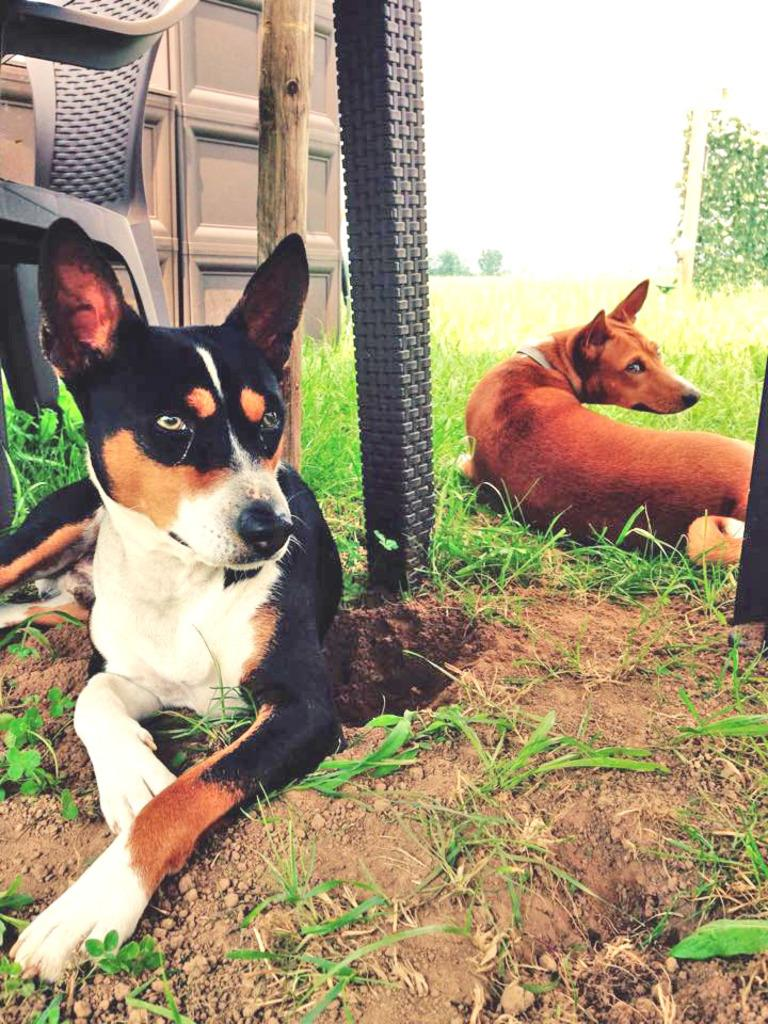How many dogs are in the image? There are two dogs sitting on the ground. What can be seen in the background of the image? There is a chair, a wooden stick, a vehicle, grass, and the sky visible in the background. What is the position of the dogs in the image? The dogs are sitting on the ground. What type of glass is being used to taste the dogs' approval in the image? There is no glass or tasting of approval present in the image; it features two dogs sitting on the ground and various background elements. 